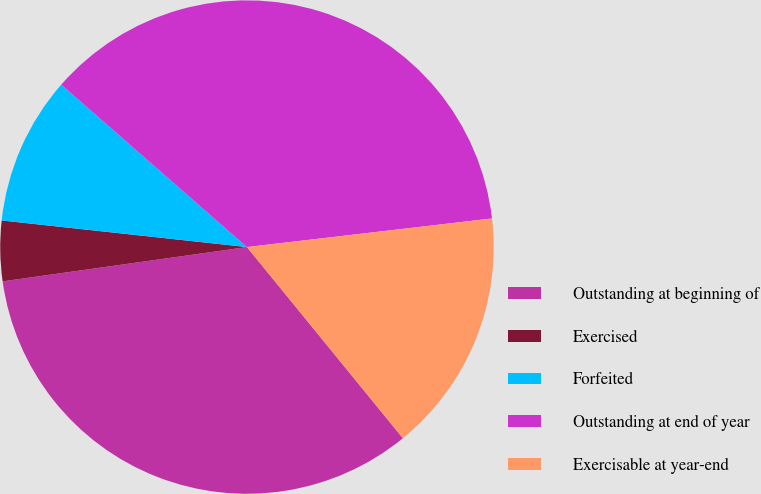Convert chart. <chart><loc_0><loc_0><loc_500><loc_500><pie_chart><fcel>Outstanding at beginning of<fcel>Exercised<fcel>Forfeited<fcel>Outstanding at end of year<fcel>Exercisable at year-end<nl><fcel>33.67%<fcel>3.94%<fcel>9.72%<fcel>36.71%<fcel>15.96%<nl></chart> 